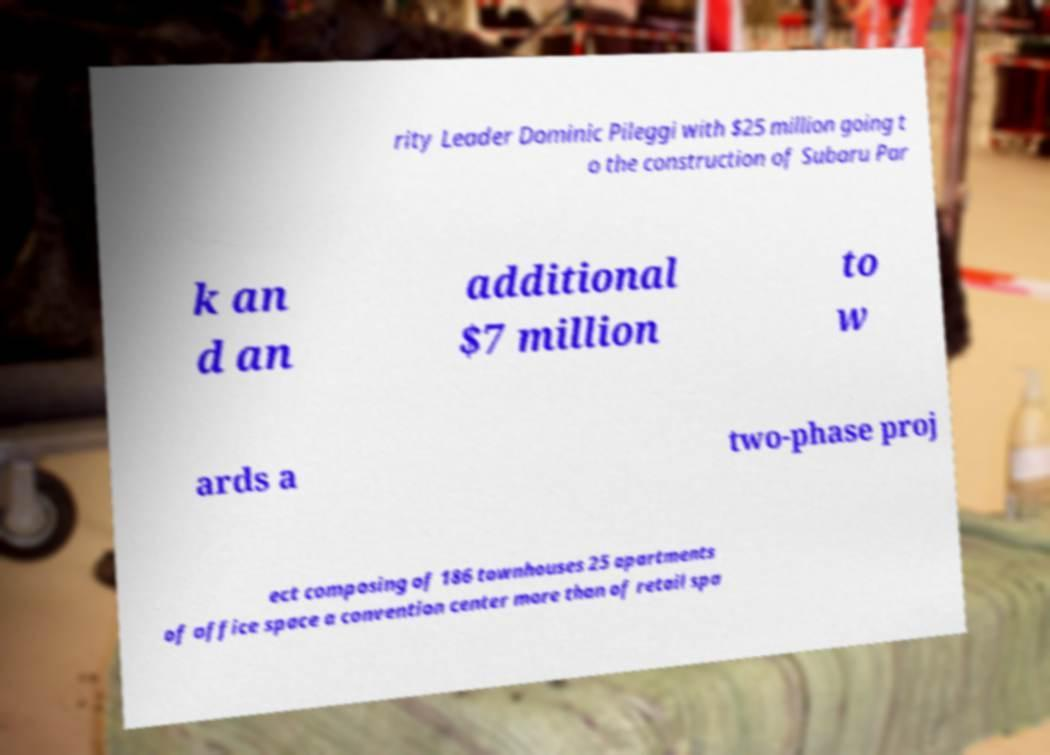Can you read and provide the text displayed in the image?This photo seems to have some interesting text. Can you extract and type it out for me? rity Leader Dominic Pileggi with $25 million going t o the construction of Subaru Par k an d an additional $7 million to w ards a two-phase proj ect composing of 186 townhouses 25 apartments of office space a convention center more than of retail spa 